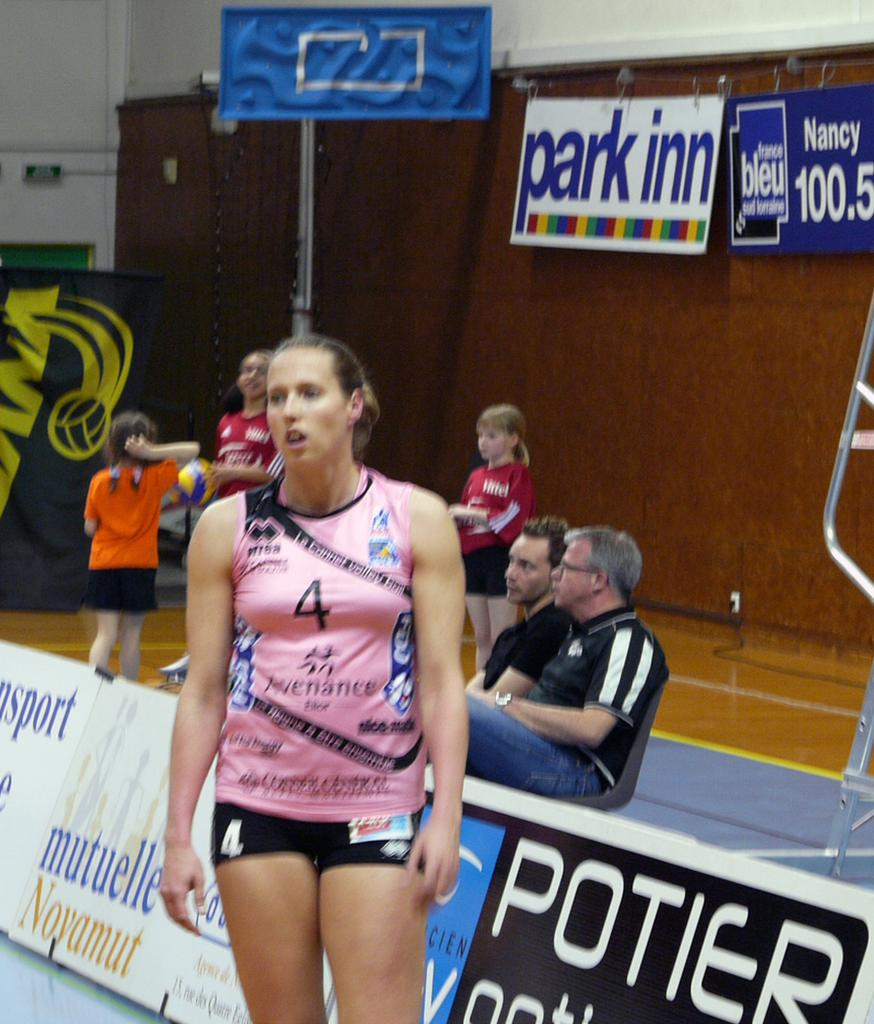<image>
Render a clear and concise summary of the photo. A girl wearing a red shirt stands beneath a sign that says park inn. 